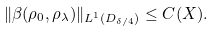Convert formula to latex. <formula><loc_0><loc_0><loc_500><loc_500>\| \beta ( \rho _ { 0 } , \rho _ { \lambda } ) \| _ { L ^ { 1 } ( D _ { \delta / 4 } ) } \leq C ( X ) .</formula> 